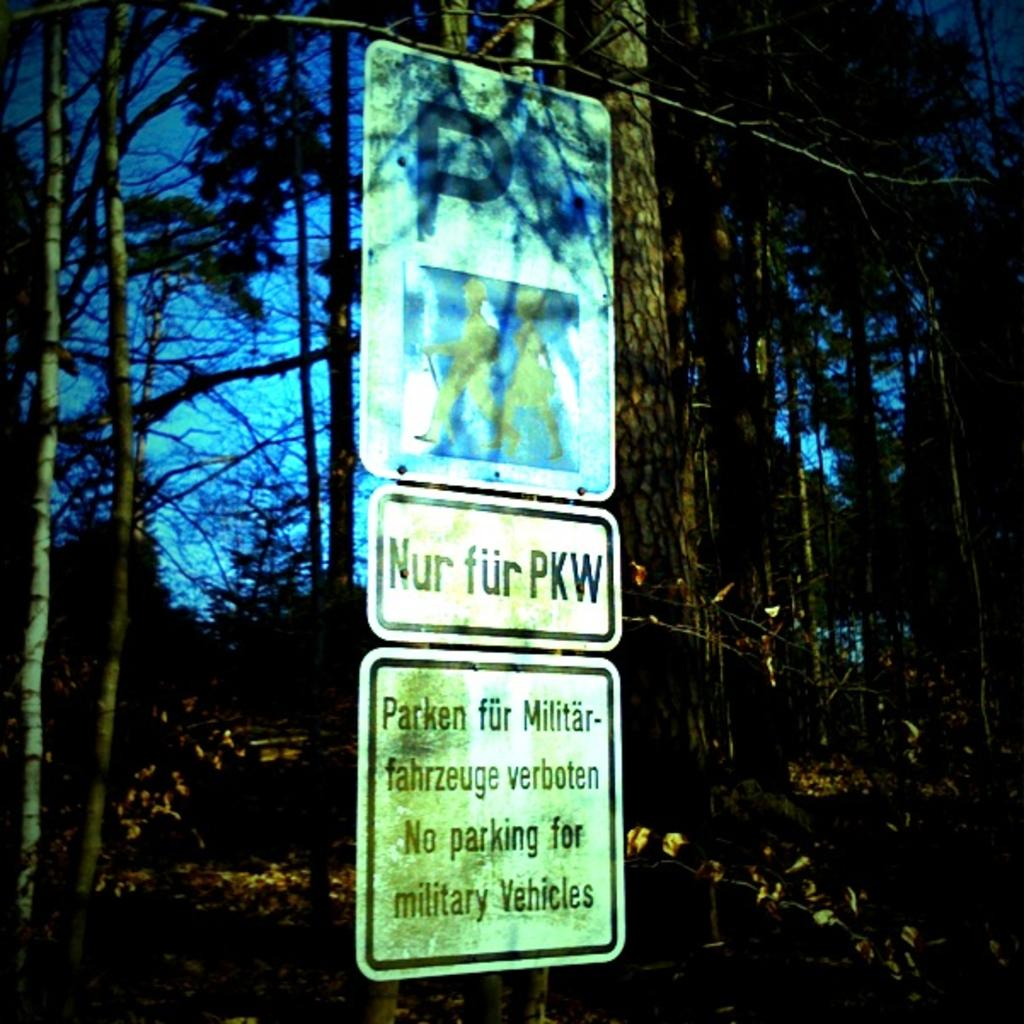What objects are in the front of the image? There are three boards in the front of the image. What is written or depicted on the boards? There is text on the boards. What can be seen in the background of the image? There are trees and the sky visible in the background of the image. How many apples are hanging from the trees in the image? There are no apples visible in the image; only trees and the sky can be seen in the background. What type of lift is present in the image? There is no lift present in the image; it features three boards with text and a background of trees and the sky. 